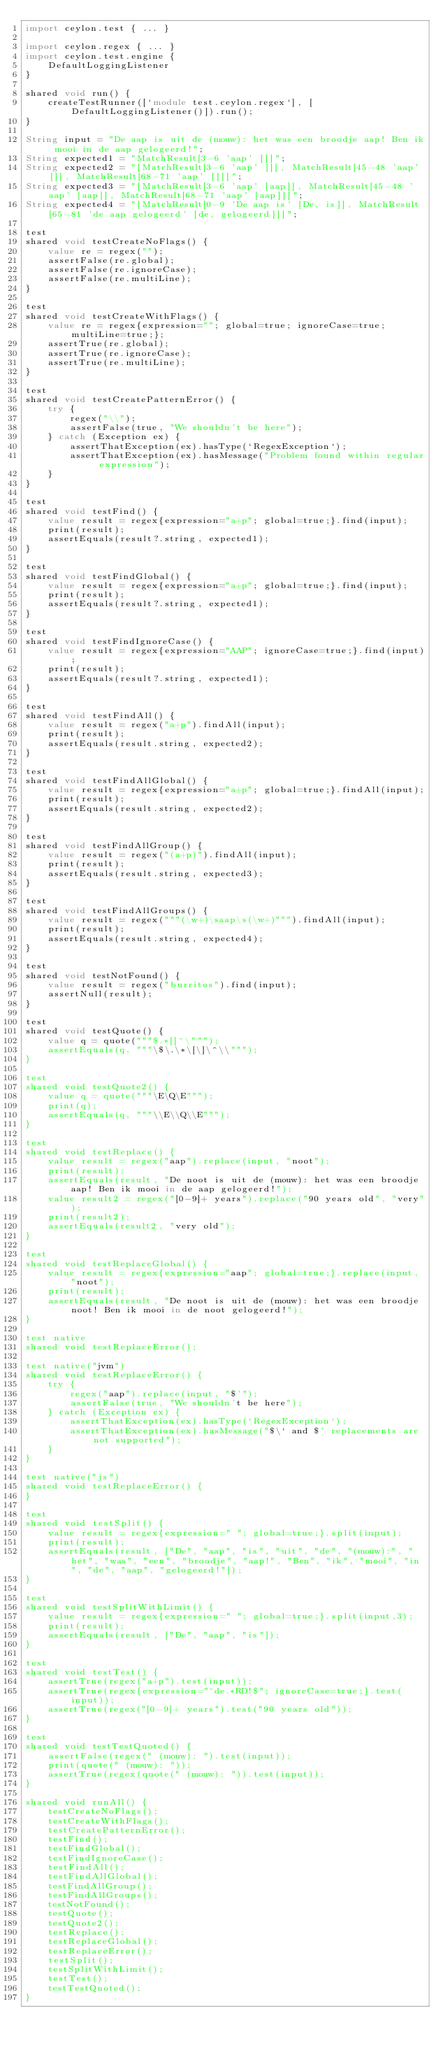Convert code to text. <code><loc_0><loc_0><loc_500><loc_500><_Ceylon_>import ceylon.test { ... }

import ceylon.regex { ... }
import ceylon.test.engine {
    DefaultLoggingListener
}

shared void run() {
    createTestRunner([`module test.ceylon.regex`], [DefaultLoggingListener()]).run();
}

String input = "De aap is uit de (mouw): het was een broodje aap! Ben ik mooi in de aap gelogeerd!";
String expected1 = "MatchResult[3-6 'aap' []]";
String expected2 = "[MatchResult[3-6 'aap' []], MatchResult[45-48 'aap' []], MatchResult[68-71 'aap' []]]";
String expected3 = "[MatchResult[3-6 'aap' [aap]], MatchResult[45-48 'aap' [aap]], MatchResult[68-71 'aap' [aap]]]";
String expected4 = "[MatchResult[0-9 'De aap is' [De, is]], MatchResult[65-81 'de aap gelogeerd' [de, gelogeerd]]]";

test
shared void testCreateNoFlags() {
    value re = regex("");
    assertFalse(re.global);
    assertFalse(re.ignoreCase);
    assertFalse(re.multiLine);
}

test
shared void testCreateWithFlags() {
    value re = regex{expression=""; global=true; ignoreCase=true; multiLine=true;};
    assertTrue(re.global);
    assertTrue(re.ignoreCase);
    assertTrue(re.multiLine);
}

test
shared void testCreatePatternError() {
    try {
        regex("\\");
        assertFalse(true, "We shouldn't be here");
    } catch (Exception ex) {
        assertThatException(ex).hasType(`RegexException`);
        assertThatException(ex).hasMessage("Problem found within regular expression");
    }
}

test
shared void testFind() {
    value result = regex{expression="a+p"; global=true;}.find(input);
    print(result);
    assertEquals(result?.string, expected1);
}

test
shared void testFindGlobal() {
    value result = regex{expression="a+p"; global=true;}.find(input);
    print(result);
    assertEquals(result?.string, expected1);
}

test
shared void testFindIgnoreCase() {
    value result = regex{expression="AAP"; ignoreCase=true;}.find(input);
    print(result);
    assertEquals(result?.string, expected1);
}

test
shared void testFindAll() {
    value result = regex("a+p").findAll(input);
    print(result);
    assertEquals(result.string, expected2);
}

test
shared void testFindAllGlobal() {
    value result = regex{expression="a+p"; global=true;}.findAll(input);
    print(result);
    assertEquals(result.string, expected2);
}

test
shared void testFindAllGroup() {
    value result = regex("(a+p)").findAll(input);
    print(result);
    assertEquals(result.string, expected3);
}

test
shared void testFindAllGroups() {
    value result = regex("""(\w+)\saap\s(\w+)""").findAll(input);
    print(result);
    assertEquals(result.string, expected4);
}

test
shared void testNotFound() {
    value result = regex("burritos").find(input);
    assertNull(result);
}

test
shared void testQuote() {
    value q = quote("""$.*[]^\""");
    assertEquals(q, """\$\.\*\[\]\^\\""");
}

test
shared void testQuote2() {
    value q = quote("""\E\Q\E""");
    print(q);
    assertEquals(q, """\\E\\Q\\E""");
}

test
shared void testReplace() {
    value result = regex("aap").replace(input, "noot");
    print(result);
    assertEquals(result, "De noot is uit de (mouw): het was een broodje aap! Ben ik mooi in de aap gelogeerd!");
    value result2 = regex("[0-9]+ years").replace("90 years old", "very");
    print(result2);
    assertEquals(result2, "very old");
}

test
shared void testReplaceGlobal() {
    value result = regex{expression="aap"; global=true;}.replace(input, "noot");
    print(result);
    assertEquals(result, "De noot is uit de (mouw): het was een broodje noot! Ben ik mooi in de noot gelogeerd!");
}

test native
shared void testReplaceError();

test native("jvm")
shared void testReplaceError() {
    try {
        regex("aap").replace(input, "$'");
        assertFalse(true, "We shouldn't be here");
    } catch (Exception ex) {
        assertThatException(ex).hasType(`RegexException`);
        assertThatException(ex).hasMessage("$\` and $' replacements are not supported");
    }
}

test native("js")
shared void testReplaceError() {
}

test
shared void testSplit() {
    value result = regex{expression=" "; global=true;}.split(input);
    print(result);
    assertEquals(result, ["De", "aap", "is", "uit", "de", "(mouw):", "het", "was", "een", "broodje", "aap!", "Ben", "ik", "mooi", "in", "de", "aap", "gelogeerd!"]);
}

test
shared void testSplitWithLimit() {
    value result = regex{expression=" "; global=true;}.split(input,3);
    print(result);
    assertEquals(result, ["De", "aap", "is"]);
}

test
shared void testTest() {
    assertTrue(regex("a+p").test(input));
    assertTrue(regex{expression="^de.*RD!$"; ignoreCase=true;}.test(input));
    assertTrue(regex("[0-9]+ years").test("90 years old"));
}

test
shared void testTestQuoted() {
    assertFalse(regex(" (mouw): ").test(input));
    print(quote(" (mouw): "));
    assertTrue(regex(quote(" (mouw): ")).test(input));
}

shared void runAll() {
    testCreateNoFlags();
    testCreateWithFlags();
    testCreatePatternError();
    testFind();
    testFindGlobal();
    testFindIgnoreCase();
    testFindAll();
    testFindAllGlobal();
    testFindAllGroup();
    testFindAllGroups();
    testNotFound();
    testQuote();
    testQuote2();
    testReplace();
    testReplaceGlobal();
    testReplaceError();
    testSplit();
    testSplitWithLimit();
    testTest();
    testTestQuoted();
}
</code> 